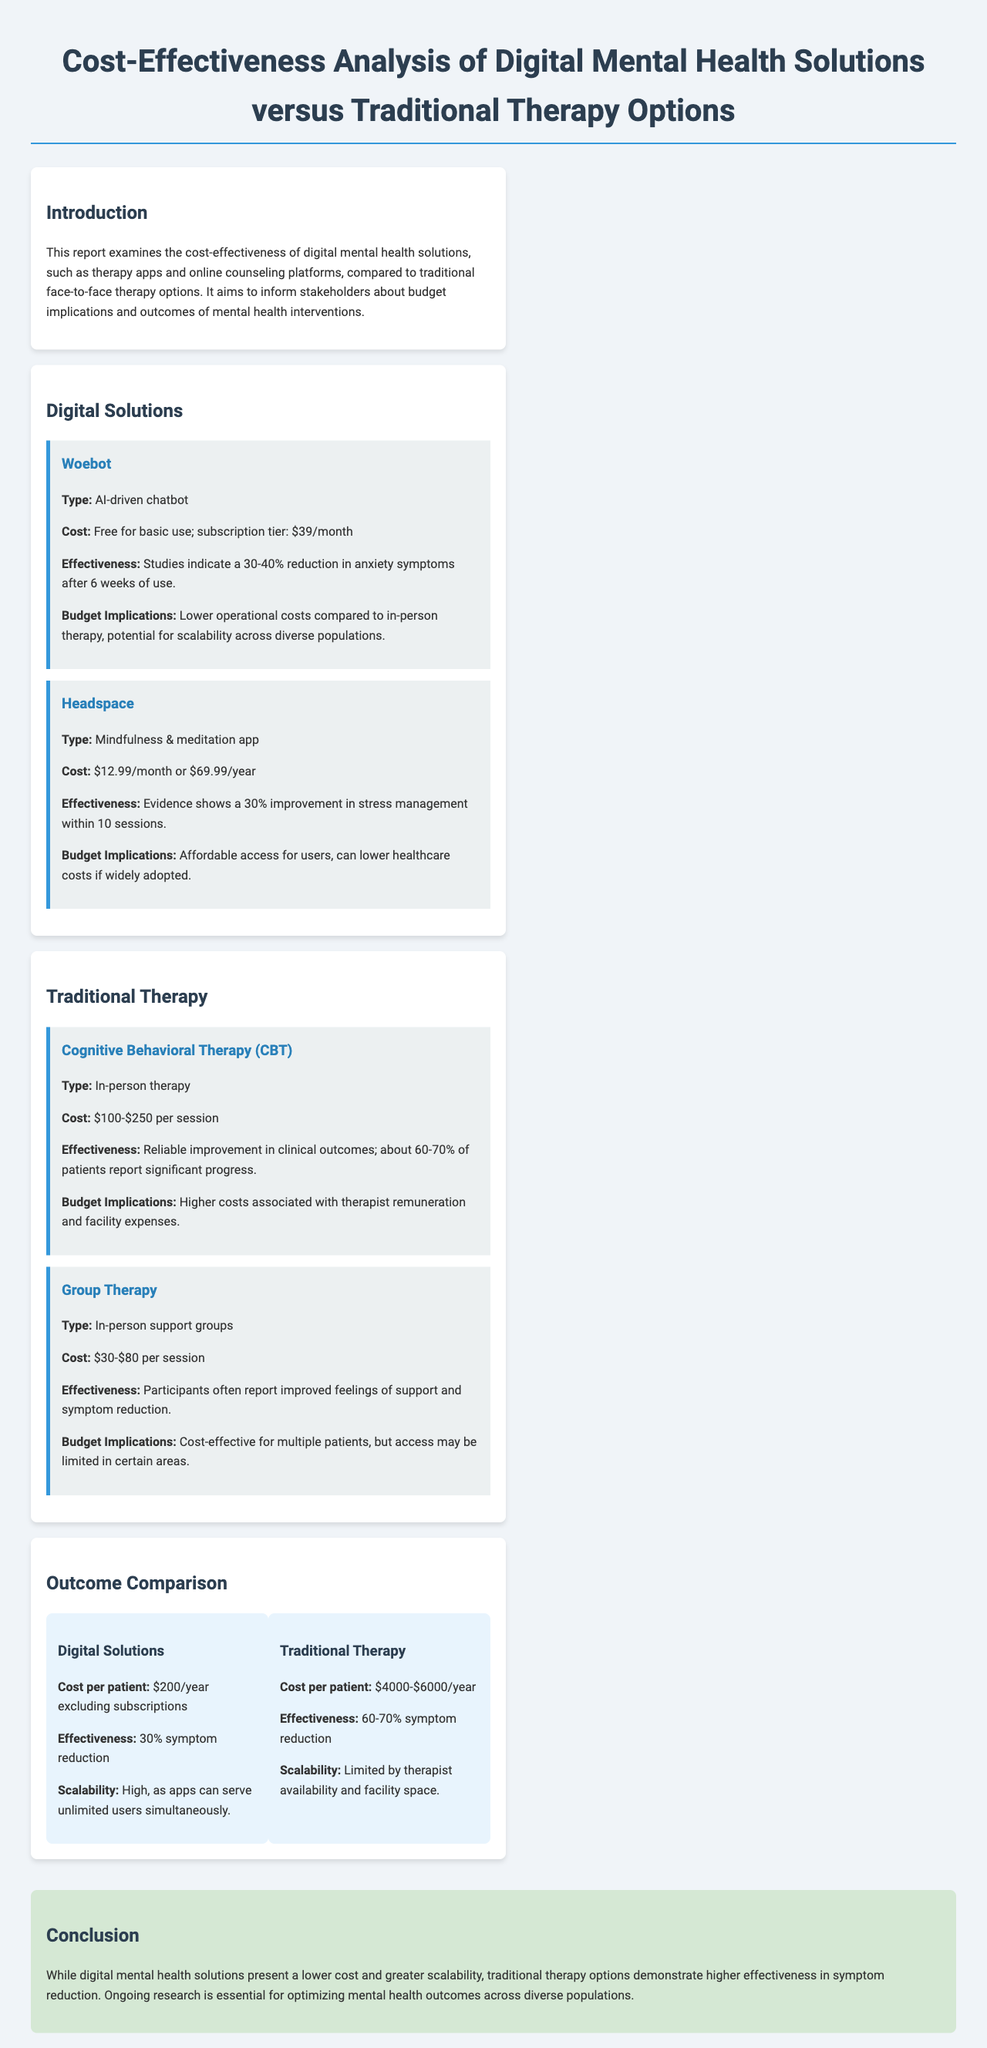What is the cost of Woebot's subscription tier? The subscription tier for Woebot is mentioned in the document as $39/month.
Answer: $39/month What percentage reduction in anxiety symptoms does Woebot provide? The document states a 30-40% reduction in anxiety symptoms after 6 weeks of use for Woebot.
Answer: 30-40% What is the cost range for Cognitive Behavioral Therapy (CBT) per session? The document specifies the cost of CBT sessions to be $100-$250 per session.
Answer: $100-$250 What does the conclusion state about traditional therapy effectiveness? The conclusion indicates that traditional therapy options demonstrate higher effectiveness in symptom reduction.
Answer: Higher effectiveness What is the effect of digital solutions on symptoms after one year? Digital solutions report a 30% symptom reduction as stated in the outcome comparison section.
Answer: 30% symptom reduction What is the cost per patient for traditional therapy? The document notes that the cost per patient for traditional therapy ranges from $4000 to $6000 per year.
Answer: $4000-$6000 How many sessions does Headspace require for a 30% improvement? The document mentions that Headspace shows a 30% improvement in stress management within 10 sessions.
Answer: 10 sessions What is noted about the scalability of digital solutions? The document highlights that digital solutions have high scalability, being able to serve unlimited users simultaneously.
Answer: High scalability 